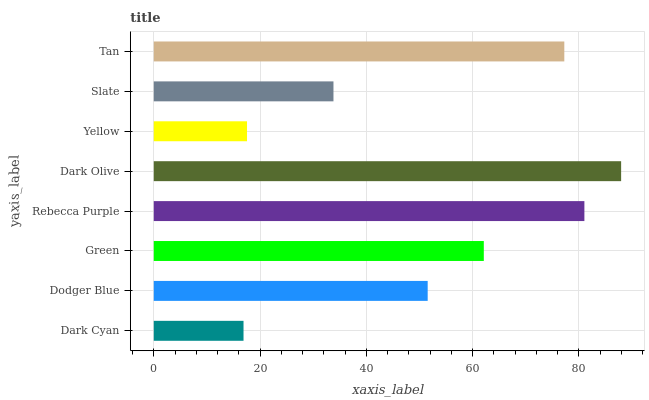Is Dark Cyan the minimum?
Answer yes or no. Yes. Is Dark Olive the maximum?
Answer yes or no. Yes. Is Dodger Blue the minimum?
Answer yes or no. No. Is Dodger Blue the maximum?
Answer yes or no. No. Is Dodger Blue greater than Dark Cyan?
Answer yes or no. Yes. Is Dark Cyan less than Dodger Blue?
Answer yes or no. Yes. Is Dark Cyan greater than Dodger Blue?
Answer yes or no. No. Is Dodger Blue less than Dark Cyan?
Answer yes or no. No. Is Green the high median?
Answer yes or no. Yes. Is Dodger Blue the low median?
Answer yes or no. Yes. Is Rebecca Purple the high median?
Answer yes or no. No. Is Green the low median?
Answer yes or no. No. 